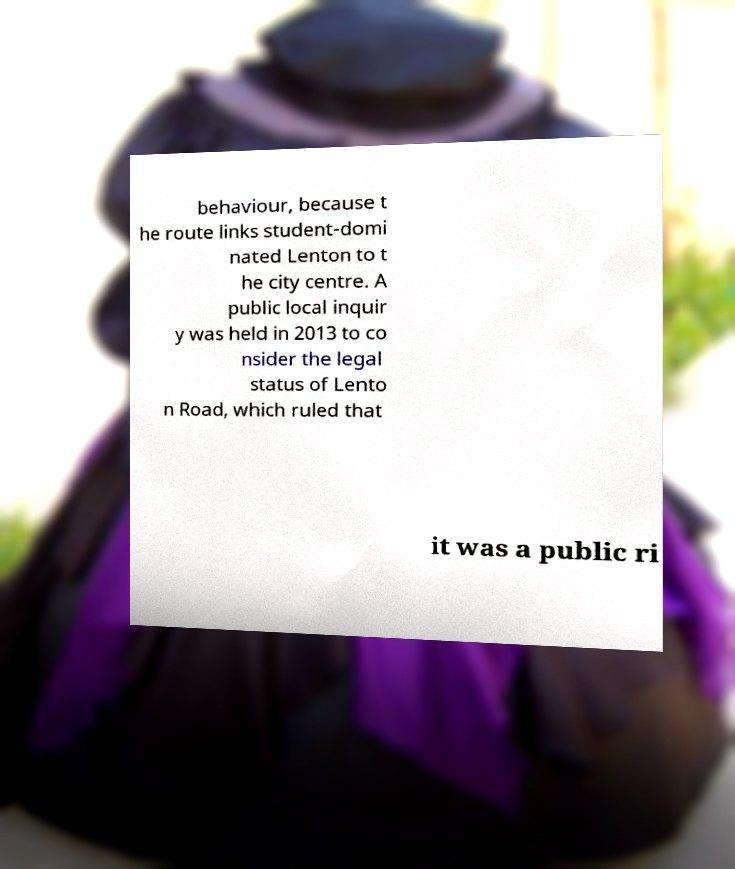What messages or text are displayed in this image? I need them in a readable, typed format. behaviour, because t he route links student-domi nated Lenton to t he city centre. A public local inquir y was held in 2013 to co nsider the legal status of Lento n Road, which ruled that it was a public ri 